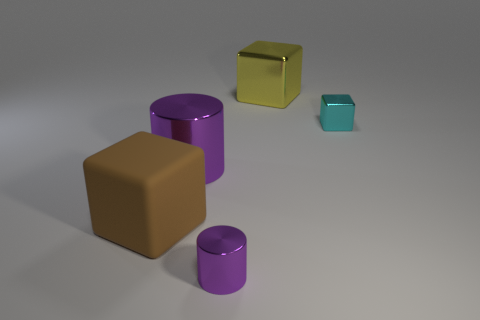Is the small cylinder the same color as the big metal cylinder?
Give a very brief answer. Yes. There is a object that is the same color as the tiny metallic cylinder; what size is it?
Provide a short and direct response. Large. Are there fewer large yellow metallic blocks than big cubes?
Provide a succinct answer. Yes. What is the shape of the big yellow thing?
Offer a very short reply. Cube. There is a big metal thing that is in front of the cyan thing; is its color the same as the small metallic cylinder?
Your answer should be compact. Yes. There is a metal thing that is behind the big purple metal cylinder and in front of the yellow shiny cube; what is its shape?
Provide a short and direct response. Cube. The small thing in front of the small cube is what color?
Your response must be concise. Purple. Is there any other thing of the same color as the large cylinder?
Provide a short and direct response. Yes. Is the brown object the same size as the yellow block?
Ensure brevity in your answer.  Yes. What is the size of the cube that is both left of the tiny cyan thing and right of the large purple metallic thing?
Your answer should be compact. Large. 